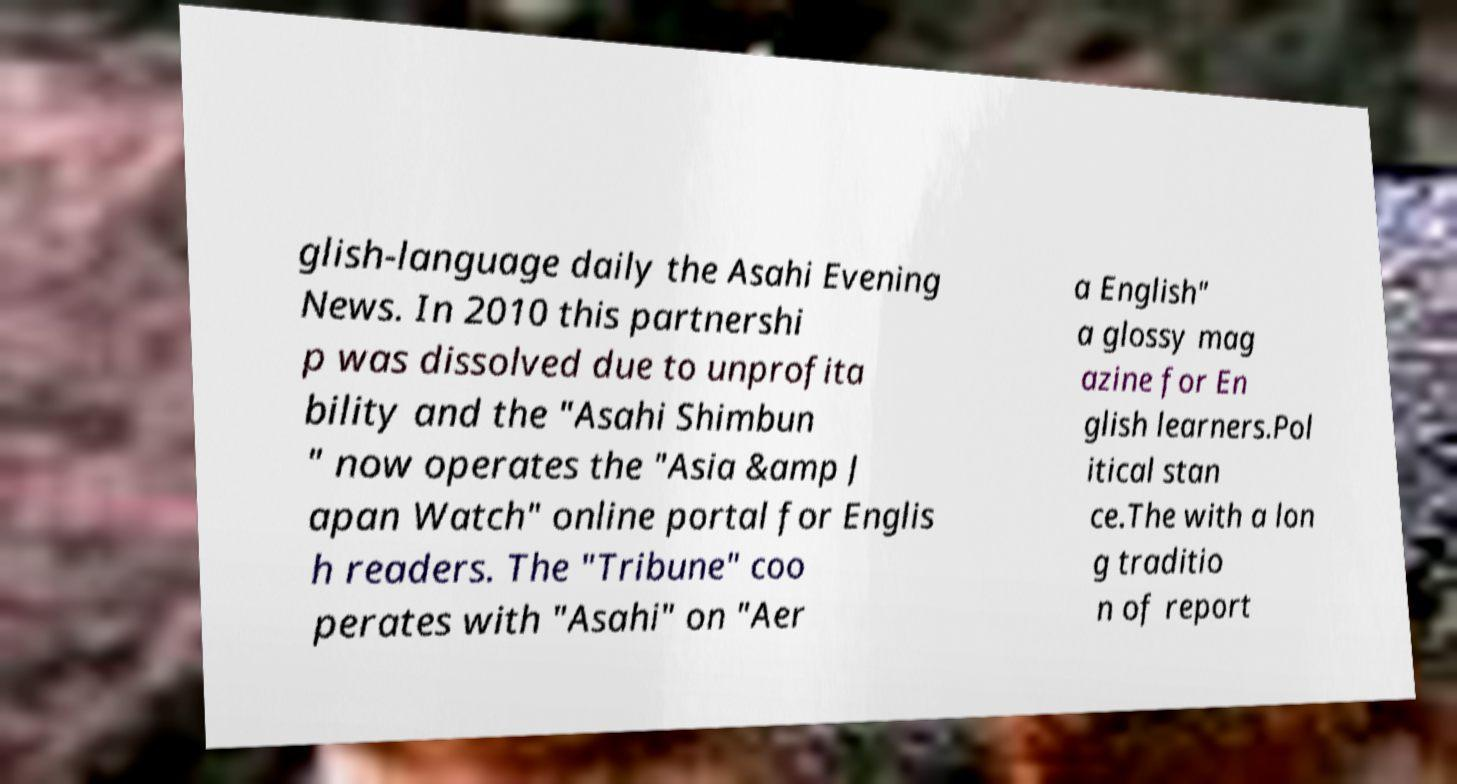Can you accurately transcribe the text from the provided image for me? glish-language daily the Asahi Evening News. In 2010 this partnershi p was dissolved due to unprofita bility and the "Asahi Shimbun " now operates the "Asia &amp J apan Watch" online portal for Englis h readers. The "Tribune" coo perates with "Asahi" on "Aer a English" a glossy mag azine for En glish learners.Pol itical stan ce.The with a lon g traditio n of report 